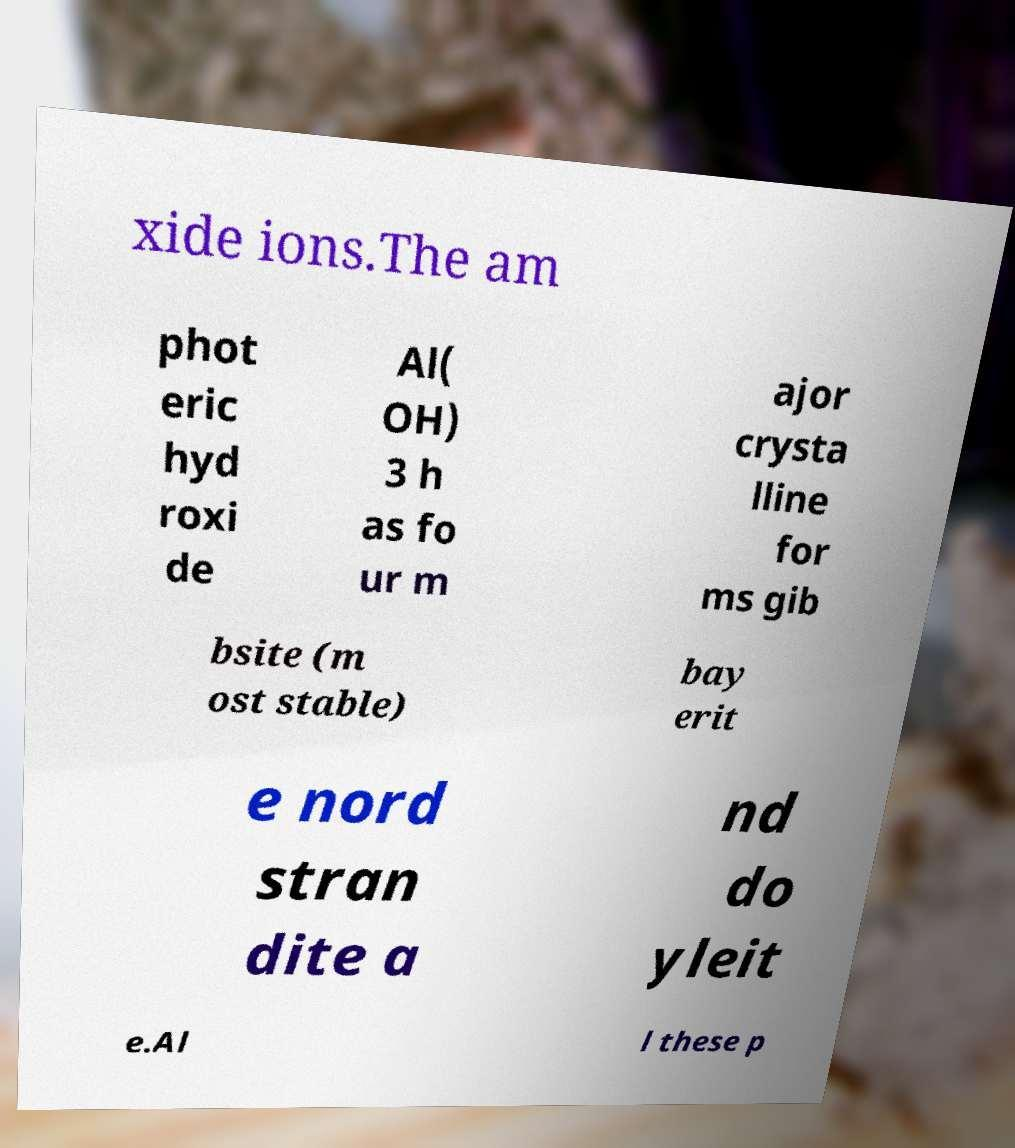Please read and relay the text visible in this image. What does it say? xide ions.The am phot eric hyd roxi de Al( OH) 3 h as fo ur m ajor crysta lline for ms gib bsite (m ost stable) bay erit e nord stran dite a nd do yleit e.Al l these p 